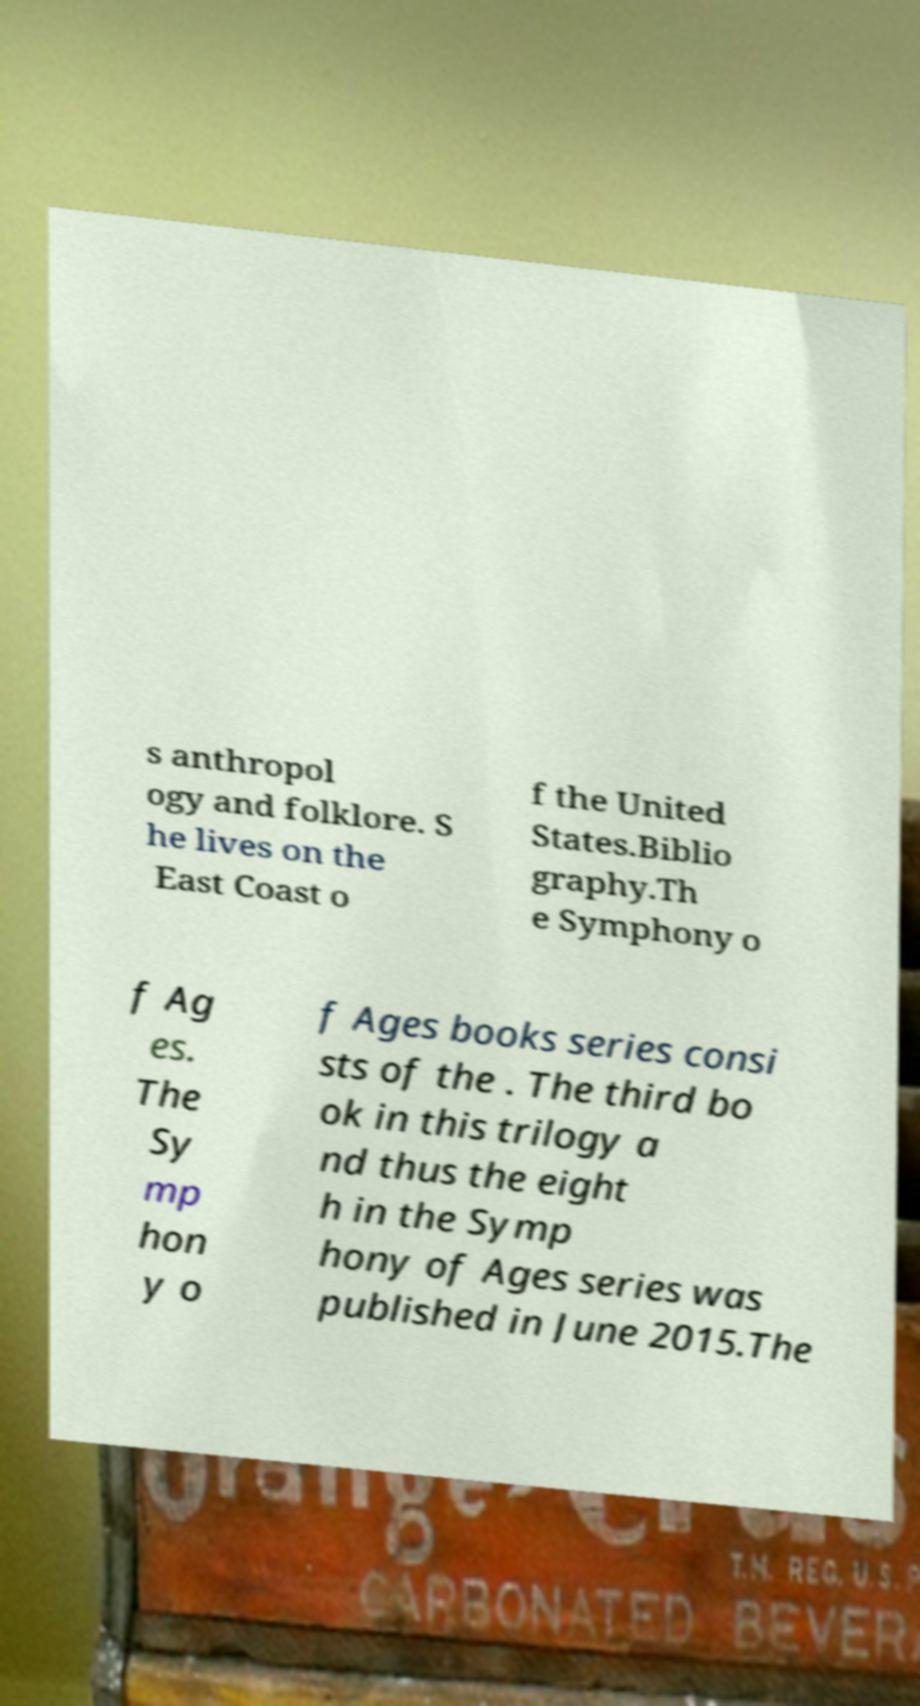I need the written content from this picture converted into text. Can you do that? s anthropol ogy and folklore. S he lives on the East Coast o f the United States.Biblio graphy.Th e Symphony o f Ag es. The Sy mp hon y o f Ages books series consi sts of the . The third bo ok in this trilogy a nd thus the eight h in the Symp hony of Ages series was published in June 2015.The 